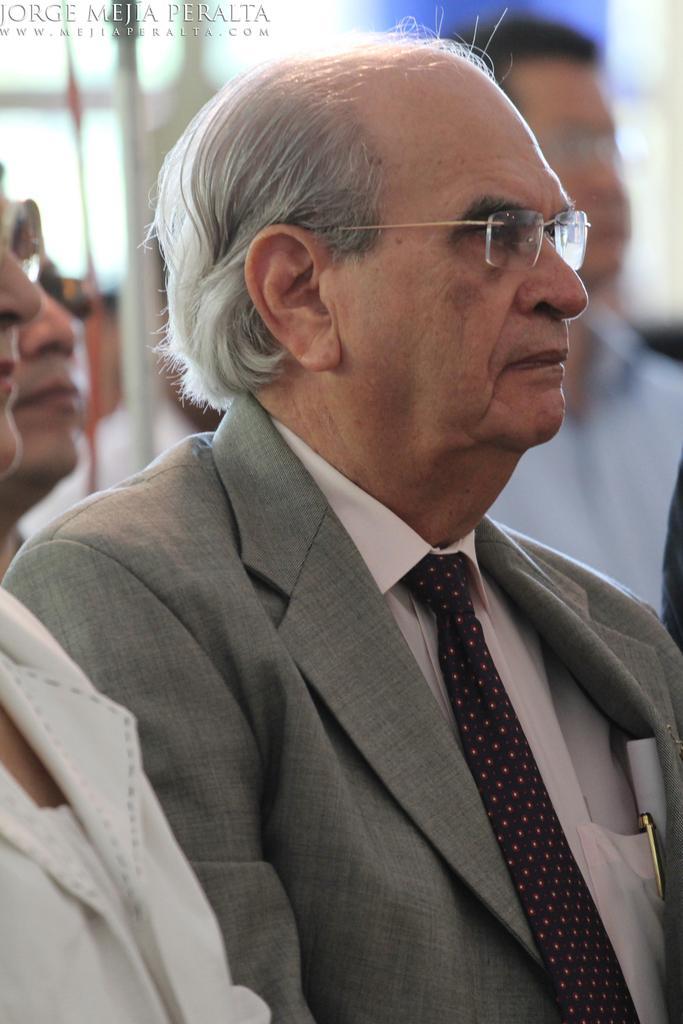Describe this image in one or two sentences. In this image there are a few men. In the center there is an old man. He is wearing a suit. There is a pen in his pocket. The background is blurry. In the top left there is text on the image. 